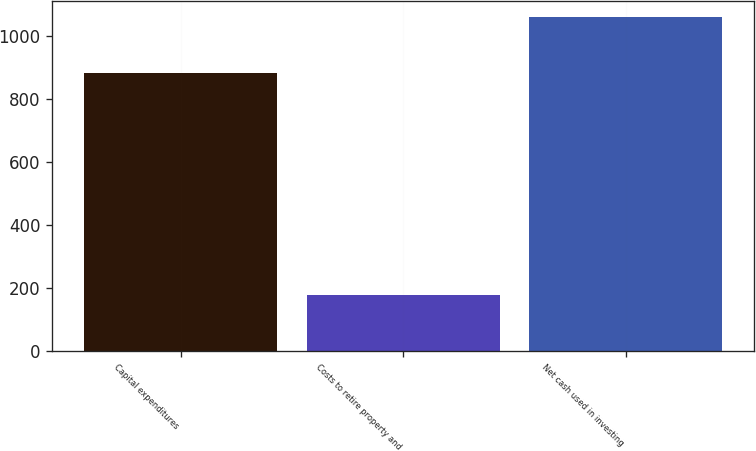Convert chart. <chart><loc_0><loc_0><loc_500><loc_500><bar_chart><fcel>Capital expenditures<fcel>Costs to retire property and<fcel>Net cash used in investing<nl><fcel>882<fcel>176<fcel>1058<nl></chart> 